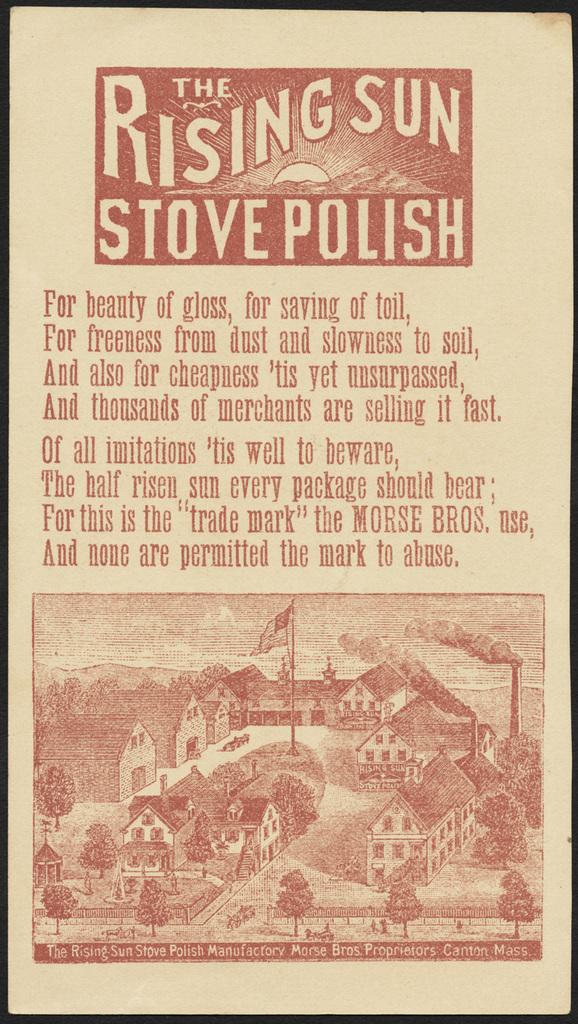<image>
Share a concise interpretation of the image provided. A sign the is titled The Rising Sun Stove Polish and a drawing of a town 